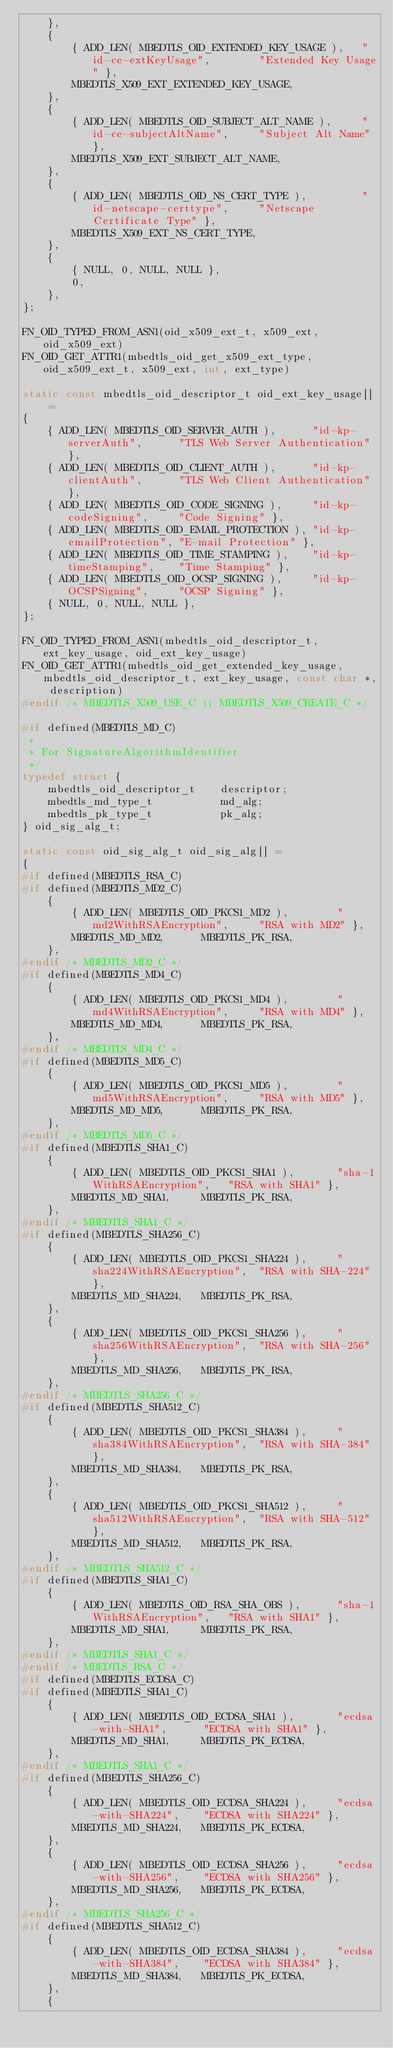Convert code to text. <code><loc_0><loc_0><loc_500><loc_500><_C_>    },
    {
        { ADD_LEN( MBEDTLS_OID_EXTENDED_KEY_USAGE ),   "id-ce-extKeyUsage",        "Extended Key Usage" },
        MBEDTLS_X509_EXT_EXTENDED_KEY_USAGE,
    },
    {
        { ADD_LEN( MBEDTLS_OID_SUBJECT_ALT_NAME ),     "id-ce-subjectAltName",     "Subject Alt Name" },
        MBEDTLS_X509_EXT_SUBJECT_ALT_NAME,
    },
    {
        { ADD_LEN( MBEDTLS_OID_NS_CERT_TYPE ),         "id-netscape-certtype",     "Netscape Certificate Type" },
        MBEDTLS_X509_EXT_NS_CERT_TYPE,
    },
    {
        { NULL, 0, NULL, NULL },
        0,
    },
};

FN_OID_TYPED_FROM_ASN1(oid_x509_ext_t, x509_ext, oid_x509_ext)
FN_OID_GET_ATTR1(mbedtls_oid_get_x509_ext_type, oid_x509_ext_t, x509_ext, int, ext_type)

static const mbedtls_oid_descriptor_t oid_ext_key_usage[] =
{
    { ADD_LEN( MBEDTLS_OID_SERVER_AUTH ),      "id-kp-serverAuth",      "TLS Web Server Authentication" },
    { ADD_LEN( MBEDTLS_OID_CLIENT_AUTH ),      "id-kp-clientAuth",      "TLS Web Client Authentication" },
    { ADD_LEN( MBEDTLS_OID_CODE_SIGNING ),     "id-kp-codeSigning",     "Code Signing" },
    { ADD_LEN( MBEDTLS_OID_EMAIL_PROTECTION ), "id-kp-emailProtection", "E-mail Protection" },
    { ADD_LEN( MBEDTLS_OID_TIME_STAMPING ),    "id-kp-timeStamping",    "Time Stamping" },
    { ADD_LEN( MBEDTLS_OID_OCSP_SIGNING ),     "id-kp-OCSPSigning",     "OCSP Signing" },
    { NULL, 0, NULL, NULL },
};

FN_OID_TYPED_FROM_ASN1(mbedtls_oid_descriptor_t, ext_key_usage, oid_ext_key_usage)
FN_OID_GET_ATTR1(mbedtls_oid_get_extended_key_usage, mbedtls_oid_descriptor_t, ext_key_usage, const char *, description)
#endif /* MBEDTLS_X509_USE_C || MBEDTLS_X509_CREATE_C */

#if defined(MBEDTLS_MD_C)
/*
 * For SignatureAlgorithmIdentifier
 */
typedef struct {
    mbedtls_oid_descriptor_t    descriptor;
    mbedtls_md_type_t           md_alg;
    mbedtls_pk_type_t           pk_alg;
} oid_sig_alg_t;

static const oid_sig_alg_t oid_sig_alg[] =
{
#if defined(MBEDTLS_RSA_C)
#if defined(MBEDTLS_MD2_C)
    {
        { ADD_LEN( MBEDTLS_OID_PKCS1_MD2 ),        "md2WithRSAEncryption",     "RSA with MD2" },
        MBEDTLS_MD_MD2,      MBEDTLS_PK_RSA,
    },
#endif /* MBEDTLS_MD2_C */
#if defined(MBEDTLS_MD4_C)
    {
        { ADD_LEN( MBEDTLS_OID_PKCS1_MD4 ),        "md4WithRSAEncryption",     "RSA with MD4" },
        MBEDTLS_MD_MD4,      MBEDTLS_PK_RSA,
    },
#endif /* MBEDTLS_MD4_C */
#if defined(MBEDTLS_MD5_C)
    {
        { ADD_LEN( MBEDTLS_OID_PKCS1_MD5 ),        "md5WithRSAEncryption",     "RSA with MD5" },
        MBEDTLS_MD_MD5,      MBEDTLS_PK_RSA,
    },
#endif /* MBEDTLS_MD5_C */
#if defined(MBEDTLS_SHA1_C)
    {
        { ADD_LEN( MBEDTLS_OID_PKCS1_SHA1 ),       "sha-1WithRSAEncryption",   "RSA with SHA1" },
        MBEDTLS_MD_SHA1,     MBEDTLS_PK_RSA,
    },
#endif /* MBEDTLS_SHA1_C */
#if defined(MBEDTLS_SHA256_C)
    {
        { ADD_LEN( MBEDTLS_OID_PKCS1_SHA224 ),     "sha224WithRSAEncryption",  "RSA with SHA-224" },
        MBEDTLS_MD_SHA224,   MBEDTLS_PK_RSA,
    },
    {
        { ADD_LEN( MBEDTLS_OID_PKCS1_SHA256 ),     "sha256WithRSAEncryption",  "RSA with SHA-256" },
        MBEDTLS_MD_SHA256,   MBEDTLS_PK_RSA,
    },
#endif /* MBEDTLS_SHA256_C */
#if defined(MBEDTLS_SHA512_C)
    {
        { ADD_LEN( MBEDTLS_OID_PKCS1_SHA384 ),     "sha384WithRSAEncryption",  "RSA with SHA-384" },
        MBEDTLS_MD_SHA384,   MBEDTLS_PK_RSA,
    },
    {
        { ADD_LEN( MBEDTLS_OID_PKCS1_SHA512 ),     "sha512WithRSAEncryption",  "RSA with SHA-512" },
        MBEDTLS_MD_SHA512,   MBEDTLS_PK_RSA,
    },
#endif /* MBEDTLS_SHA512_C */
#if defined(MBEDTLS_SHA1_C)
    {
        { ADD_LEN( MBEDTLS_OID_RSA_SHA_OBS ),      "sha-1WithRSAEncryption",   "RSA with SHA1" },
        MBEDTLS_MD_SHA1,     MBEDTLS_PK_RSA,
    },
#endif /* MBEDTLS_SHA1_C */
#endif /* MBEDTLS_RSA_C */
#if defined(MBEDTLS_ECDSA_C)
#if defined(MBEDTLS_SHA1_C)
    {
        { ADD_LEN( MBEDTLS_OID_ECDSA_SHA1 ),       "ecdsa-with-SHA1",      "ECDSA with SHA1" },
        MBEDTLS_MD_SHA1,     MBEDTLS_PK_ECDSA,
    },
#endif /* MBEDTLS_SHA1_C */
#if defined(MBEDTLS_SHA256_C)
    {
        { ADD_LEN( MBEDTLS_OID_ECDSA_SHA224 ),     "ecdsa-with-SHA224",    "ECDSA with SHA224" },
        MBEDTLS_MD_SHA224,   MBEDTLS_PK_ECDSA,
    },
    {
        { ADD_LEN( MBEDTLS_OID_ECDSA_SHA256 ),     "ecdsa-with-SHA256",    "ECDSA with SHA256" },
        MBEDTLS_MD_SHA256,   MBEDTLS_PK_ECDSA,
    },
#endif /* MBEDTLS_SHA256_C */
#if defined(MBEDTLS_SHA512_C)
    {
        { ADD_LEN( MBEDTLS_OID_ECDSA_SHA384 ),     "ecdsa-with-SHA384",    "ECDSA with SHA384" },
        MBEDTLS_MD_SHA384,   MBEDTLS_PK_ECDSA,
    },
    {</code> 